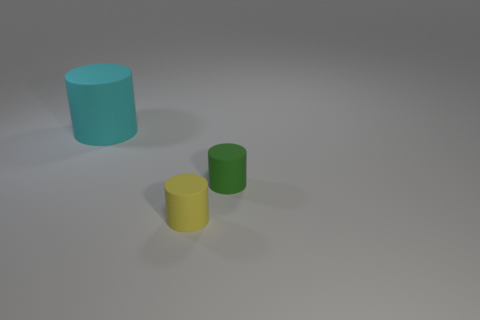There is another small object that is the same material as the tiny green thing; what is its color? yellow 